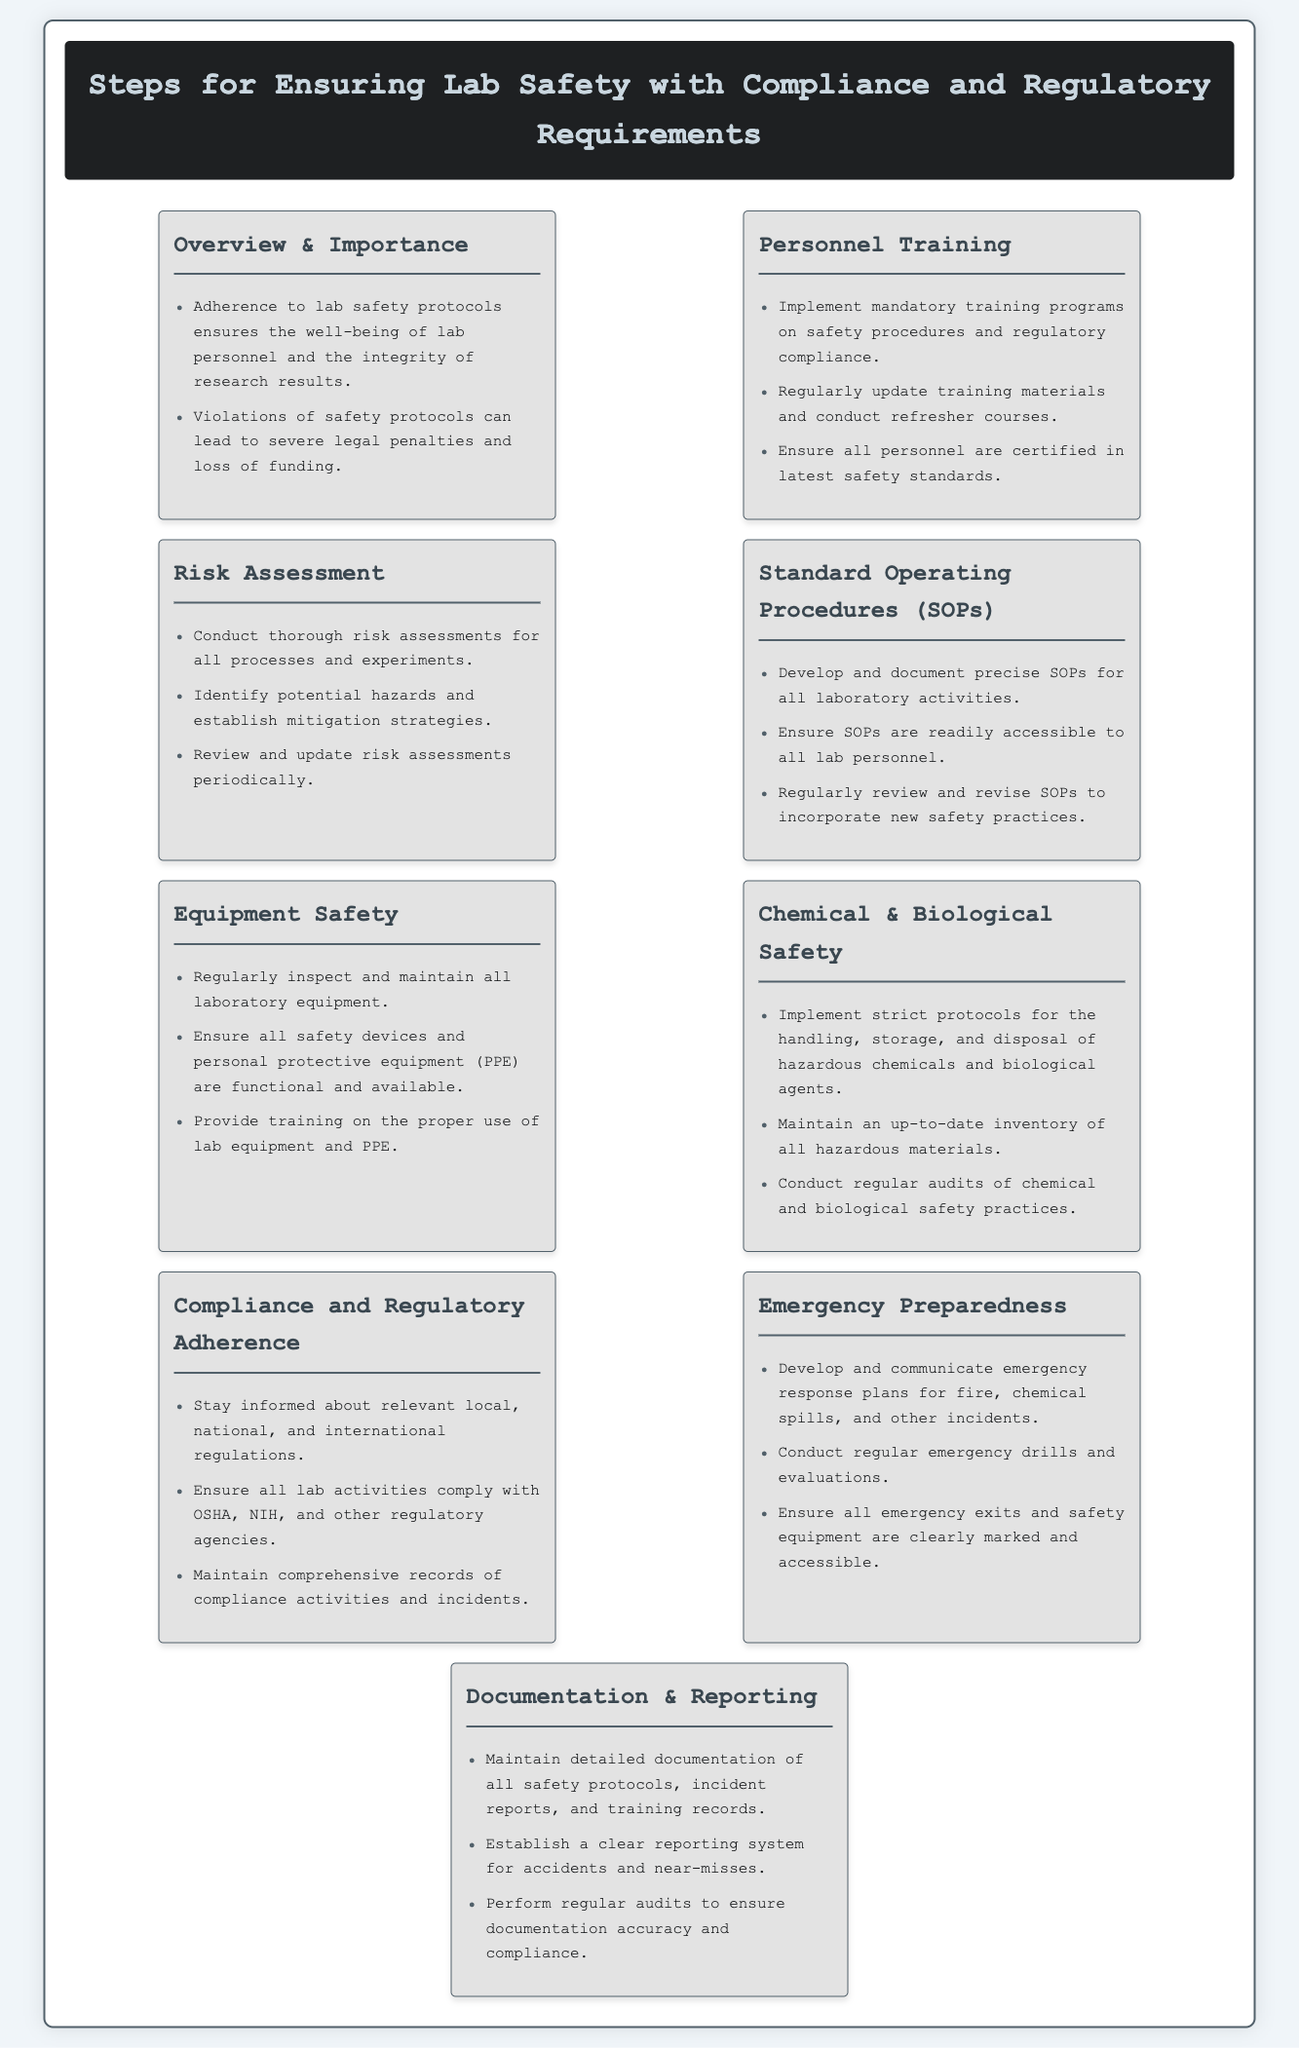what is the title of the infographic? The title of the infographic appears at the top and summarizes the document's content.
Answer: Steps for Ensuring Lab Safety with Compliance and Regulatory Requirements what is one key reason for adhering to lab safety protocols? The document lists reasons for adhering to protocols, focusing on personnel and research integrity.
Answer: Well-being of lab personnel how many sections are included in the infographic? The infographic is organized into several main sections, each addressing different aspects of lab safety.
Answer: Eight what must be implemented for ensuring personnel training? The infographic specifies a type of training required for lab personnel.
Answer: Mandatory training programs which regulatory agencies must compliance be ensured with? The document mentions specific agencies relevant to lab safety compliance.
Answer: OSHA, NIH what is required for chemical and biological safety protocols? The infographic outlines crucial requirements for handling hazardous materials.
Answer: Strict protocols how often should risk assessments be reviewed? The document indicates the frequency of updates for risk assessments to maintain safety.
Answer: Periodically what is the purpose of maintaining detailed documentation? The infographic highlights an important aspect of lab safety related to records.
Answer: Ensure compliance how often should emergency drills be conducted? The document emphasizes the importance of frequency in emergency readiness evaluations.
Answer: Regularly 